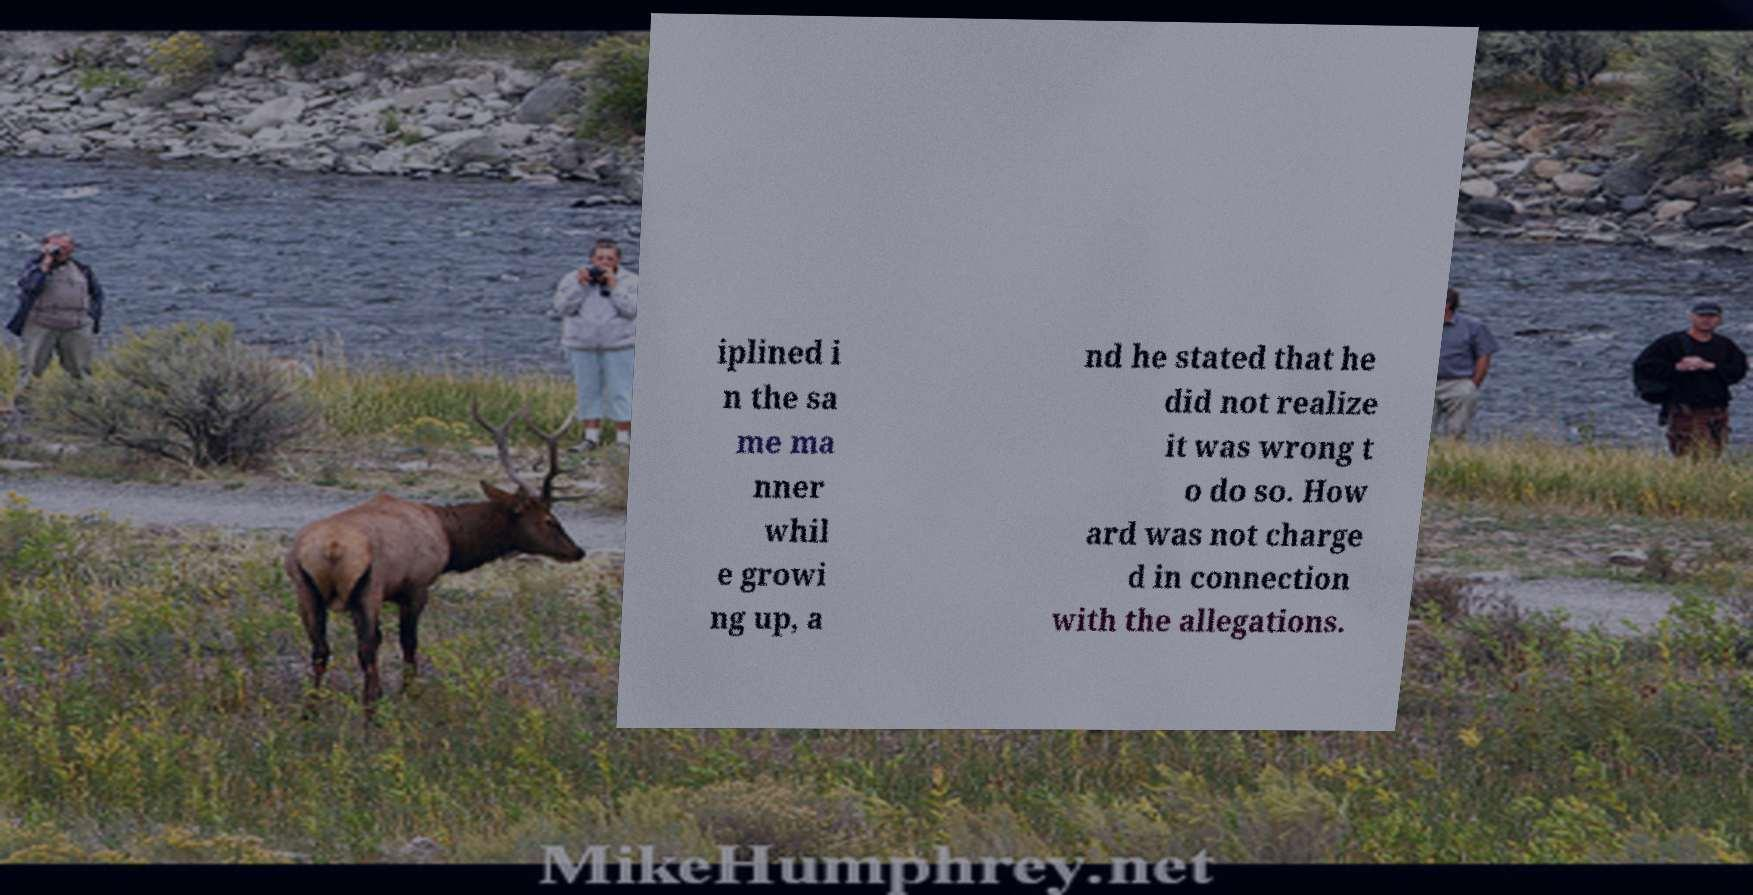I need the written content from this picture converted into text. Can you do that? iplined i n the sa me ma nner whil e growi ng up, a nd he stated that he did not realize it was wrong t o do so. How ard was not charge d in connection with the allegations. 